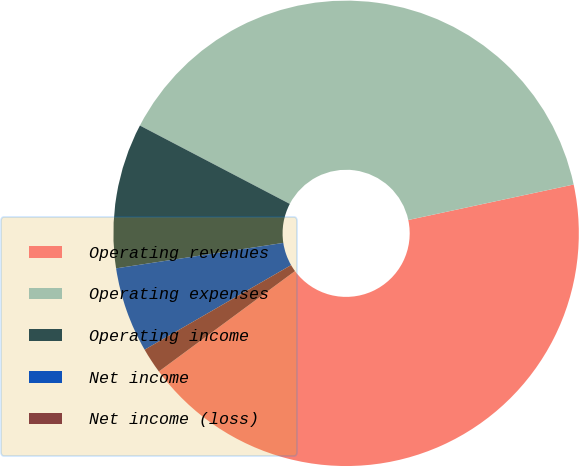Convert chart to OTSL. <chart><loc_0><loc_0><loc_500><loc_500><pie_chart><fcel>Operating revenues<fcel>Operating expenses<fcel>Operating income<fcel>Net income<fcel>Net income (loss)<nl><fcel>43.25%<fcel>38.97%<fcel>10.07%<fcel>5.93%<fcel>1.78%<nl></chart> 